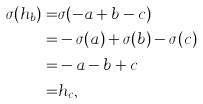<formula> <loc_0><loc_0><loc_500><loc_500>\sigma ( h _ { b } ) = & \sigma ( - a + b - c ) \\ = & - \sigma ( a ) + \sigma ( b ) - \sigma ( c ) \\ = & - a - b + c \\ = & h _ { c } ,</formula> 